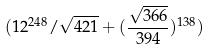<formula> <loc_0><loc_0><loc_500><loc_500>( 1 2 ^ { 2 4 8 } / \sqrt { 4 2 1 } + ( \frac { \sqrt { 3 6 6 } } { 3 9 4 } ) ^ { 1 3 8 } )</formula> 